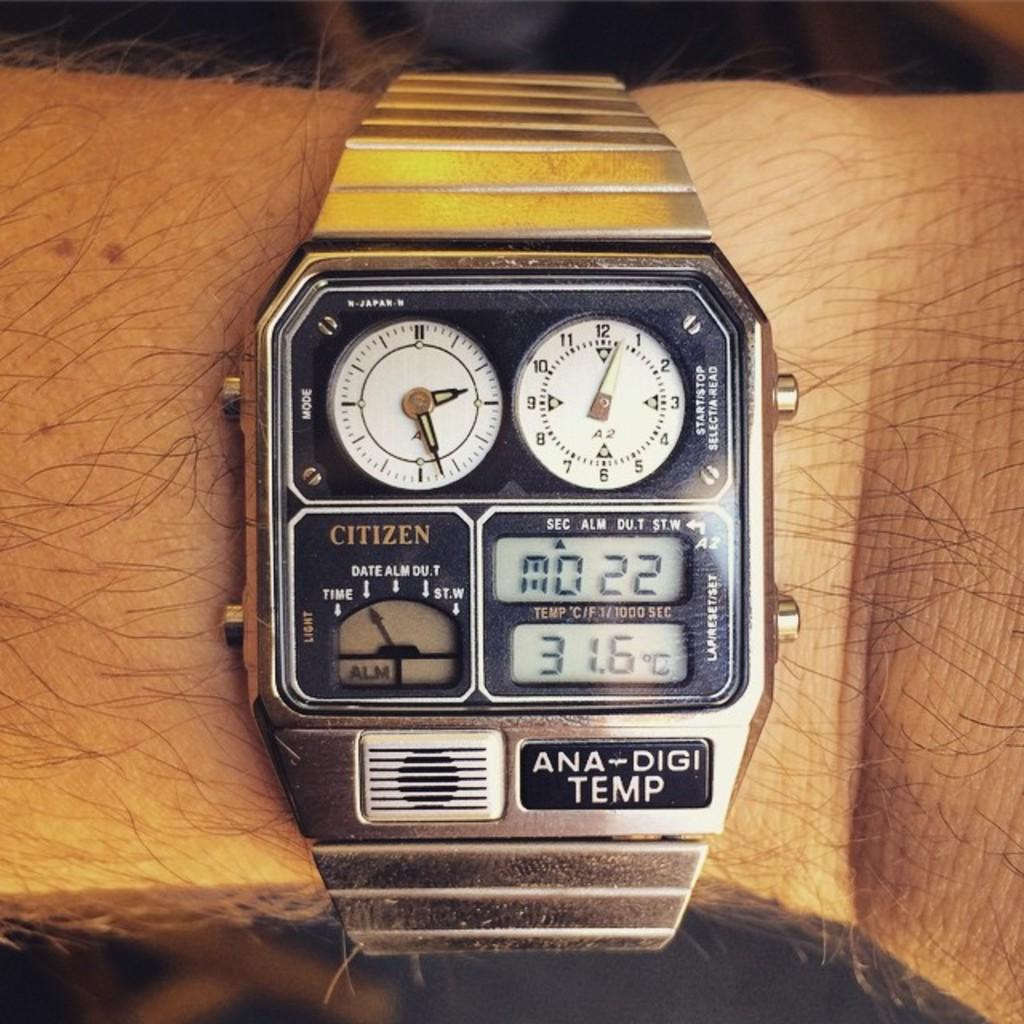<image>
Create a compact narrative representing the image presented. a watch that says 'ana-digi temp' on it and 'citizen' on the screen 